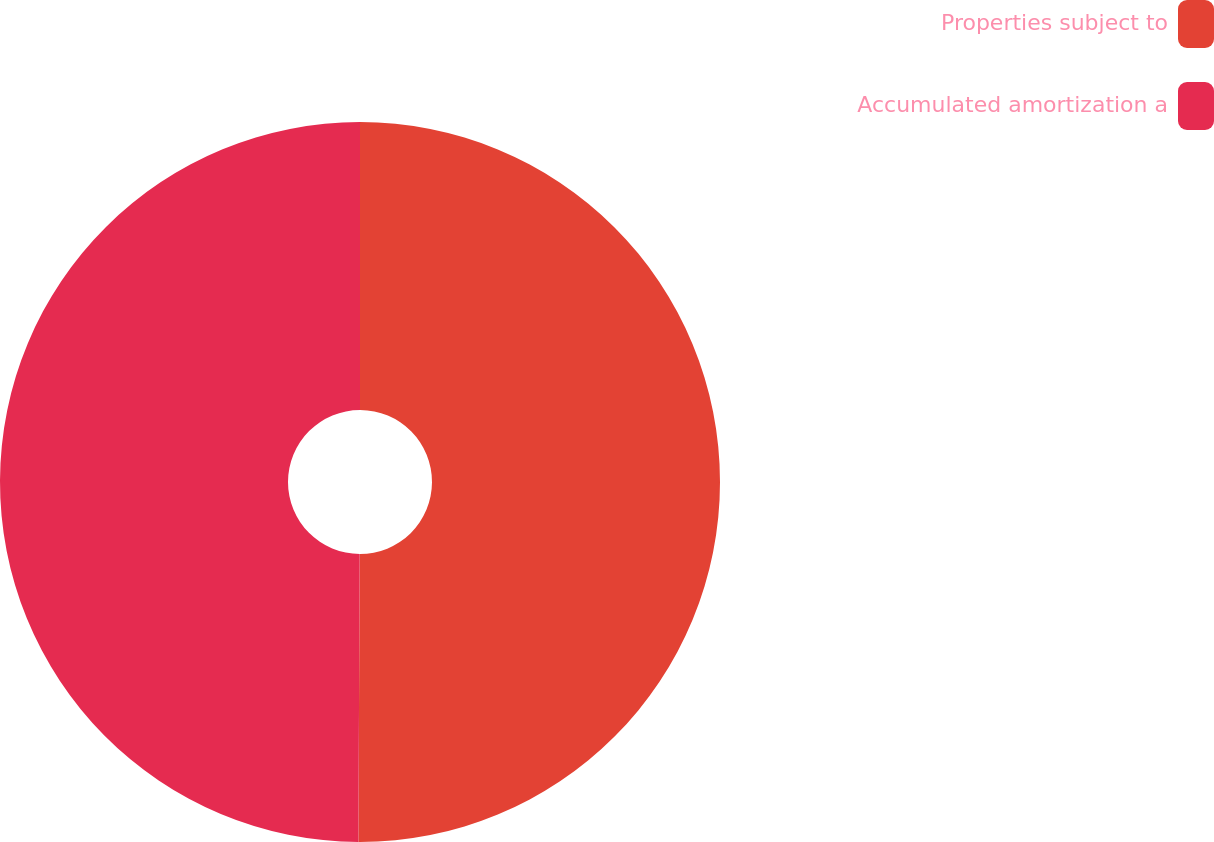<chart> <loc_0><loc_0><loc_500><loc_500><pie_chart><fcel>Properties subject to<fcel>Accumulated amortization a<nl><fcel>50.07%<fcel>49.93%<nl></chart> 